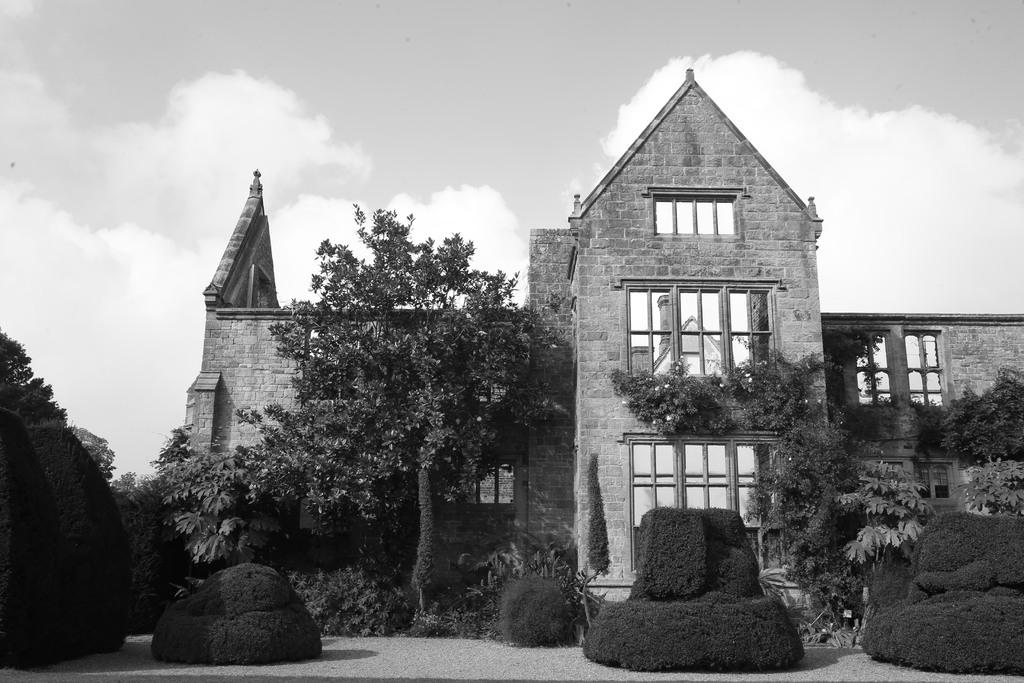What type of structure is visible in the image? There is a building with windows in the image. What natural elements can be seen in the image? There are trees and plants in the image. What is visible in the background of the image? The sky is visible in the background of the image. What can be observed in the sky? Clouds are present in the sky. What type of lace can be seen on the building in the image? There is no lace present on the building in the image. Is there a crook visible in the image? There is no crook present in the image. 